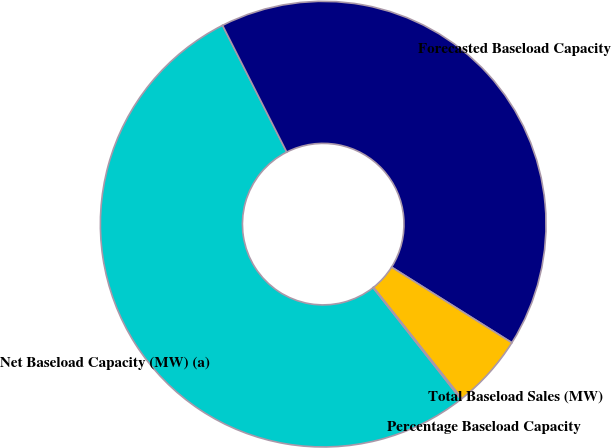Convert chart to OTSL. <chart><loc_0><loc_0><loc_500><loc_500><pie_chart><fcel>Net Baseload Capacity (MW) (a)<fcel>Forecasted Baseload Capacity<fcel>Total Baseload Sales (MW)<fcel>Percentage Baseload Capacity<nl><fcel>53.15%<fcel>41.39%<fcel>5.38%<fcel>0.08%<nl></chart> 